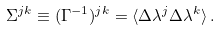Convert formula to latex. <formula><loc_0><loc_0><loc_500><loc_500>\Sigma ^ { j k } \equiv ( \Gamma ^ { - 1 } ) ^ { j k } = \langle \Delta \lambda ^ { j } \Delta \lambda ^ { k } \rangle \, .</formula> 